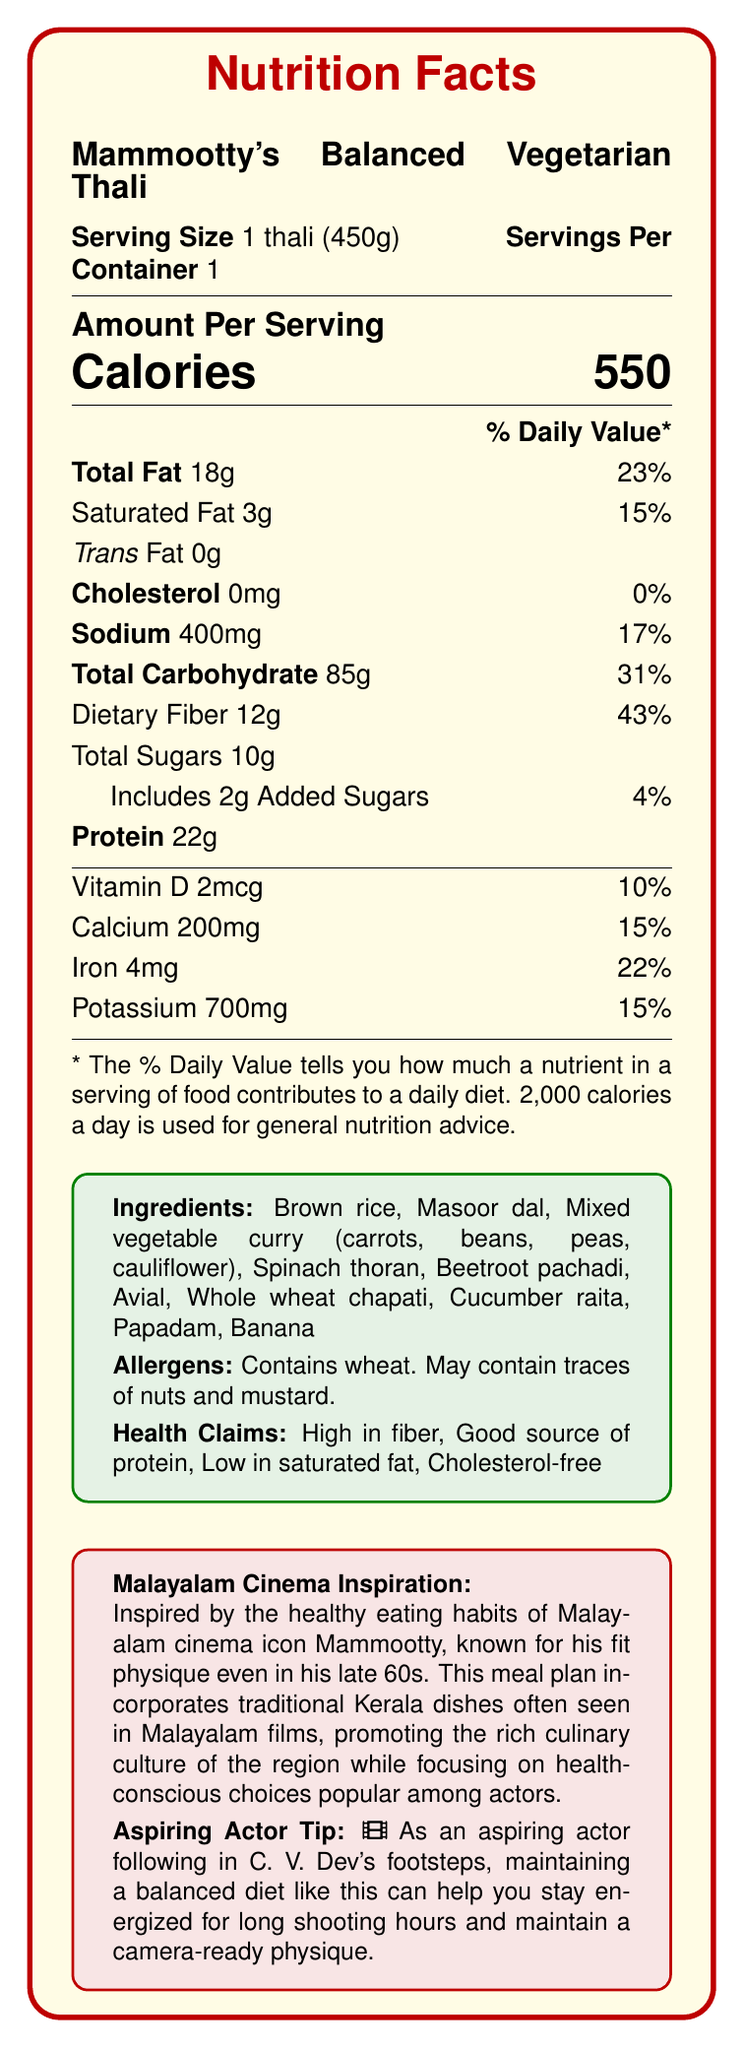What is the serving size of Mammootty's Balanced Vegetarian Thali? The serving size is specified as "1 thali (450g)" in the document.
Answer: 1 thali (450g) What percentage of the daily value for dietary fiber does one serving of the thali provide? The document indicates that one serving of the thali provides 43% of the daily value for dietary fiber.
Answer: 43% What are the ingredients in Mammootty's Balanced Vegetarian Thali? The document lists all these items as ingredients.
Answer: Brown rice, Masoor dal, Mixed vegetable curry (carrots, beans, peas, cauliflower), Spinach thoran, Beetroot pachadi, Avial, Whole wheat chapati, Cucumber raita, Papadam, Banana How much protein does one serving of Mammootty's Balanced Vegetarian Thali contain? The nutrition facts state that there are 22g of protein per serving.
Answer: 22g What is the amount of sodium per serving in Mammootty's Balanced Vegetarian Thali? The document specifies that there is 400mg of sodium per serving.
Answer: 400mg Which of the following nutrients is not found in Mammootty's Balanced Vegetarian Thali? A. Vitamin D B. Calcium C. Cholesterol D. Potassium The document states that the thali contains 0mg of cholesterol.
Answer: C. Cholesterol What is the percentage of daily value for calcium provided by one serving of the Thali? A. 10% B. 15% C. 22% D. 43% The document indicates that one serving provides 15% of the daily value for calcium.
Answer: B. 15% Does Mammootty's Balanced Vegetarian Thali contain any trans fat? The nutrition facts show that it contains 0g of trans fat.
Answer: No Is this meal suitable for someone looking for a cholesterol-free diet? The document explicitly states that the meal is cholesterol-free.
Answer: Yes Summarize the main idea of Mammootty's Balanced Vegetarian Thali document. The summary captures the overall nutritional content, ingredients, health focuses, and inspiration behind the meal plan, emphasizing its health benefits and cultural connection.
Answer: The document describes the nutritional information, ingredients, allergens, and health benefits of Mammootty's Balanced Vegetarian Thali, inspired by Malayalam cinema icon Mammootty. The meal is designed to be healthy, high in fiber, and low in saturated fat, suitable for health-conscious individuals following traditional Kerala cuisine. What is the specific dietary fiber amount that contributes to the 43% daily value in the thali? The document provides the percentage (43%) but does not translate it to a specific amount beyond the total dietary fiber in grams (12g), so the specific calculation contributing to the daily value cannot be confirmed directly from the document.
Answer: Cannot be determined 